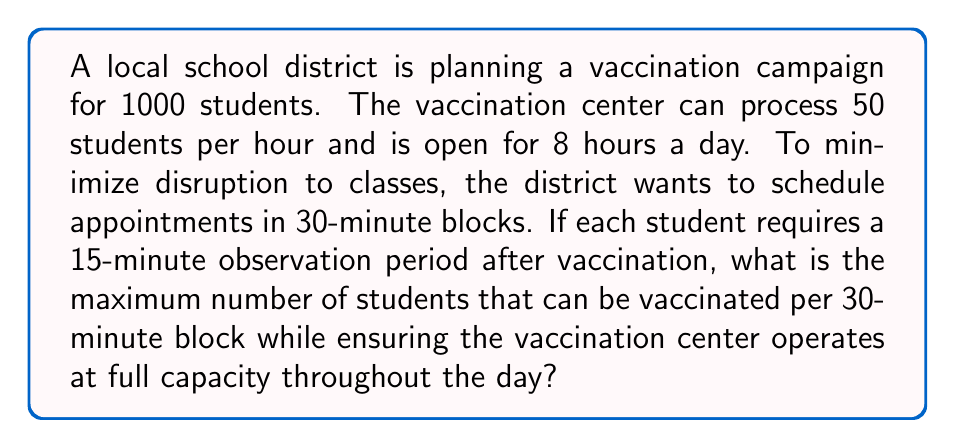What is the answer to this math problem? Let's approach this problem step-by-step:

1) First, we need to calculate the total number of students that can be vaccinated in a day:
   $$ \text{Students per day} = 50 \text{ students/hour} \times 8 \text{ hours} = 400 \text{ students} $$

2) Now, we need to determine how many 30-minute blocks are in an 8-hour day:
   $$ \text{Number of blocks} = \frac{8 \text{ hours}}{0.5 \text{ hours/block}} = 16 \text{ blocks} $$

3) To operate at full capacity, we need to vaccinate 400 students in 16 blocks. Let's call the number of students per block $x$:
   $$ 16x = 400 $$
   $$ x = 25 \text{ students per block} $$

4) Now we need to check if this is feasible given the 15-minute observation period:
   - In a 30-minute block, we have:
     $$ \text{Time for vaccinations} = 30 \text{ minutes} - 15 \text{ minutes} = 15 \text{ minutes} $$
   - The vaccination rate is 50 students per hour, or $\frac{50}{60} = \frac{5}{6}$ students per minute
   - In 15 minutes, we can vaccinate:
     $$ \frac{5}{6} \text{ students/minute} \times 15 \text{ minutes} = 12.5 \text{ students} $$

5) Since we can only vaccinate whole numbers of students, we round down to 12 students per 30-minute block.

This is less than the 25 students per block needed to operate at full capacity. Therefore, we need to adjust our approach.

6) If we vaccinate 12 students in the first 15 minutes of a block, they can be in observation for the second 15 minutes while another 12 students are being vaccinated.

7) This gives us a total of 24 students per 30-minute block, which is the maximum possible while ensuring full capacity operation.
Answer: The maximum number of students that can be vaccinated per 30-minute block while ensuring the vaccination center operates at full capacity is 24 students. 